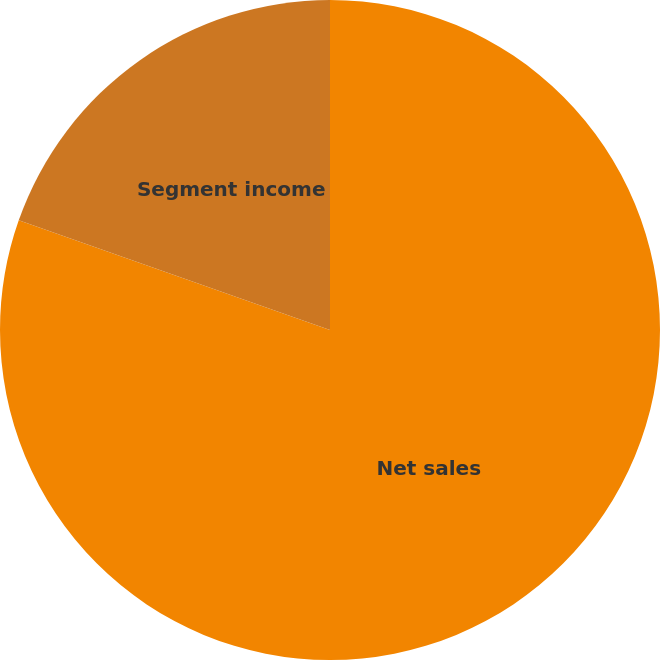Convert chart to OTSL. <chart><loc_0><loc_0><loc_500><loc_500><pie_chart><fcel>Net sales<fcel>Segment income<nl><fcel>80.39%<fcel>19.61%<nl></chart> 